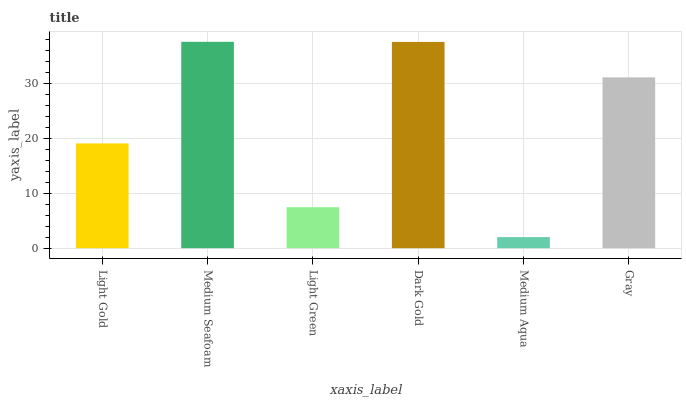Is Medium Aqua the minimum?
Answer yes or no. Yes. Is Medium Seafoam the maximum?
Answer yes or no. Yes. Is Light Green the minimum?
Answer yes or no. No. Is Light Green the maximum?
Answer yes or no. No. Is Medium Seafoam greater than Light Green?
Answer yes or no. Yes. Is Light Green less than Medium Seafoam?
Answer yes or no. Yes. Is Light Green greater than Medium Seafoam?
Answer yes or no. No. Is Medium Seafoam less than Light Green?
Answer yes or no. No. Is Gray the high median?
Answer yes or no. Yes. Is Light Gold the low median?
Answer yes or no. Yes. Is Dark Gold the high median?
Answer yes or no. No. Is Medium Seafoam the low median?
Answer yes or no. No. 